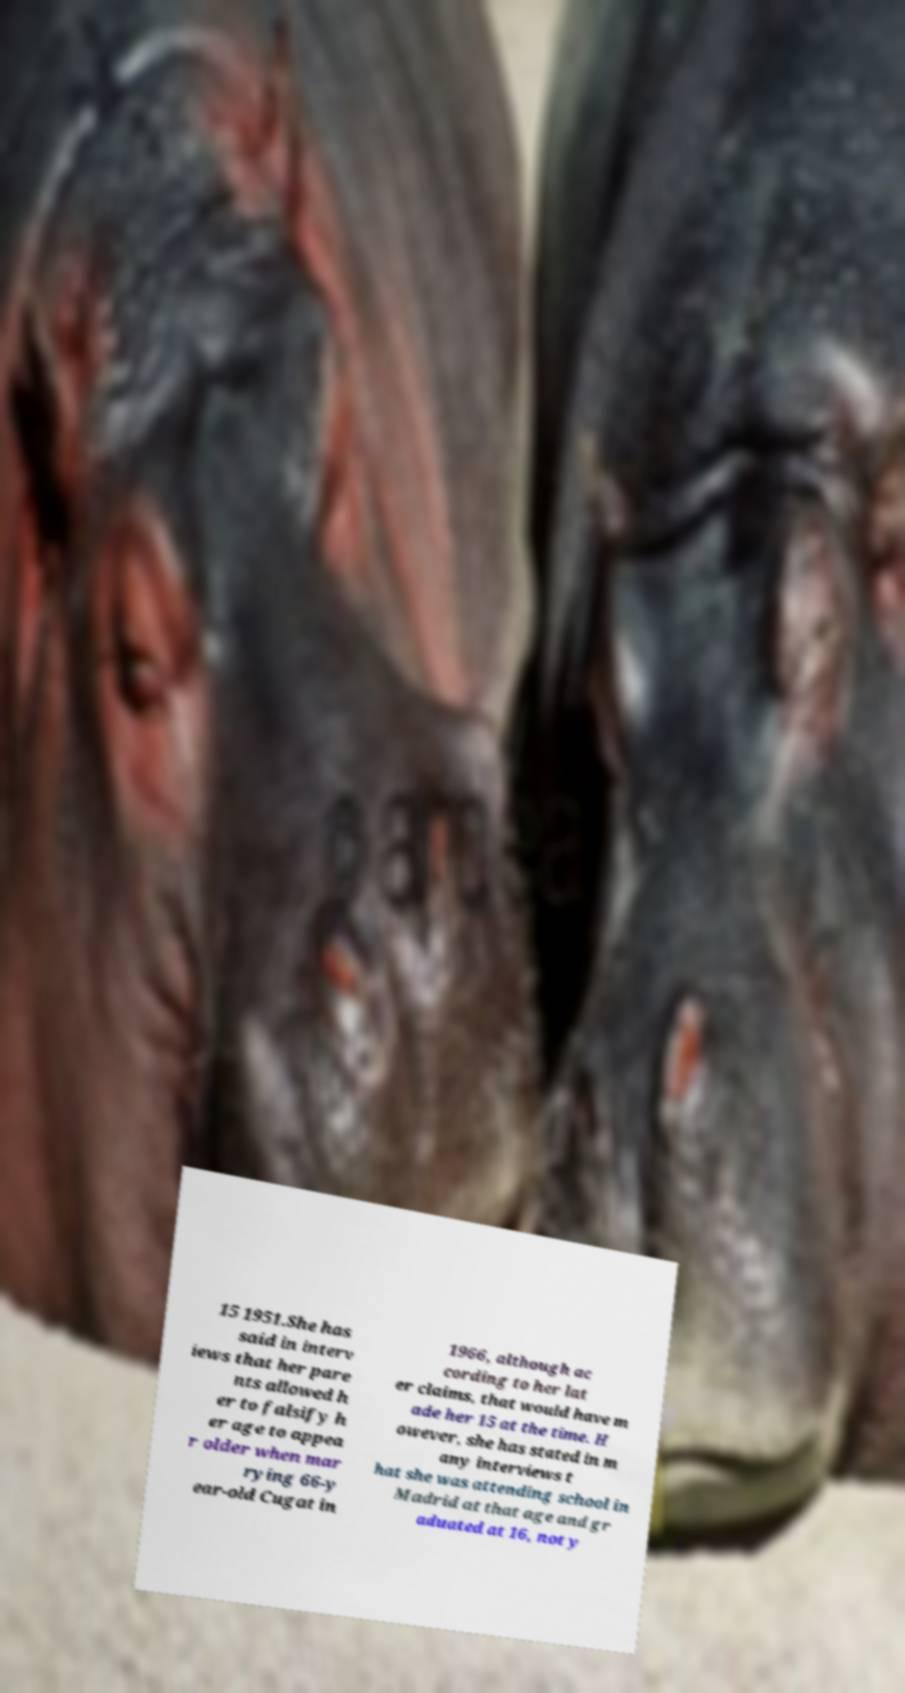There's text embedded in this image that I need extracted. Can you transcribe it verbatim? 15 1951.She has said in interv iews that her pare nts allowed h er to falsify h er age to appea r older when mar rying 66-y ear-old Cugat in 1966, although ac cording to her lat er claims, that would have m ade her 15 at the time. H owever, she has stated in m any interviews t hat she was attending school in Madrid at that age and gr aduated at 16, not y 